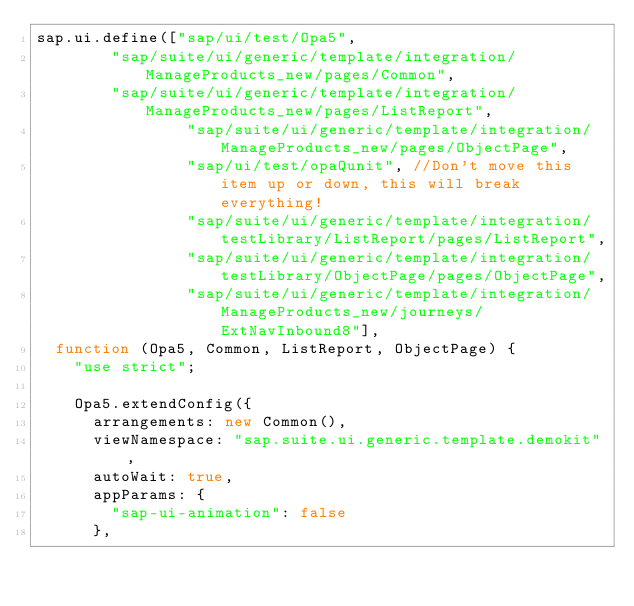Convert code to text. <code><loc_0><loc_0><loc_500><loc_500><_JavaScript_>sap.ui.define(["sap/ui/test/Opa5",
				"sap/suite/ui/generic/template/integration/ManageProducts_new/pages/Common",
				"sap/suite/ui/generic/template/integration/ManageProducts_new/pages/ListReport",
                "sap/suite/ui/generic/template/integration/ManageProducts_new/pages/ObjectPage",
                "sap/ui/test/opaQunit", //Don't move this item up or down, this will break everything!
                "sap/suite/ui/generic/template/integration/testLibrary/ListReport/pages/ListReport",
                "sap/suite/ui/generic/template/integration/testLibrary/ObjectPage/pages/ObjectPage",
                "sap/suite/ui/generic/template/integration/ManageProducts_new/journeys/ExtNavInbound8"],
	function (Opa5, Common, ListReport, ObjectPage) {
		"use strict";

		Opa5.extendConfig({
			arrangements: new Common(),
			viewNamespace: "sap.suite.ui.generic.template.demokit",
			autoWait: true,
			appParams: {
				"sap-ui-animation": false
			},</code> 